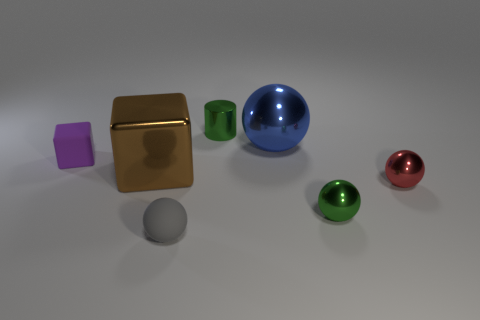Subtract 1 spheres. How many spheres are left? 3 Add 2 blue cylinders. How many objects exist? 9 Subtract all cylinders. How many objects are left? 6 Subtract all small red balls. Subtract all small gray balls. How many objects are left? 5 Add 1 green balls. How many green balls are left? 2 Add 4 purple matte objects. How many purple matte objects exist? 5 Subtract 0 gray cylinders. How many objects are left? 7 